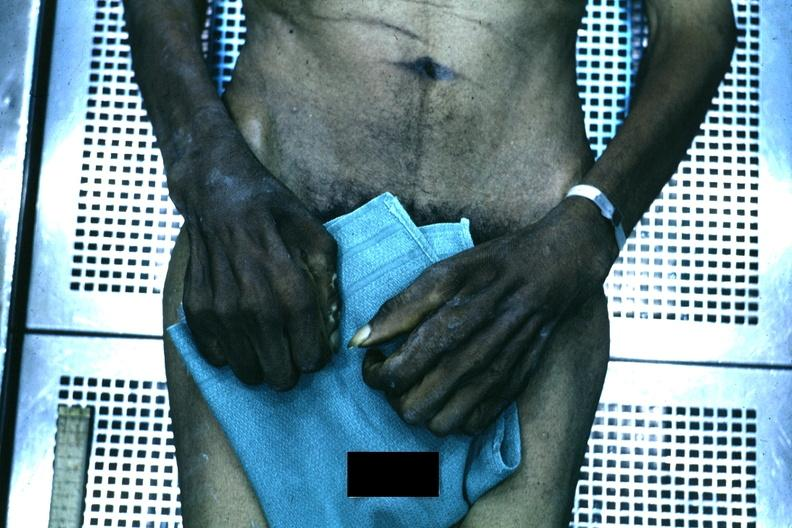why does this image show good example of muscle atrophy said to be?
Answer the question using a single word or phrase. Due syringomyelia 